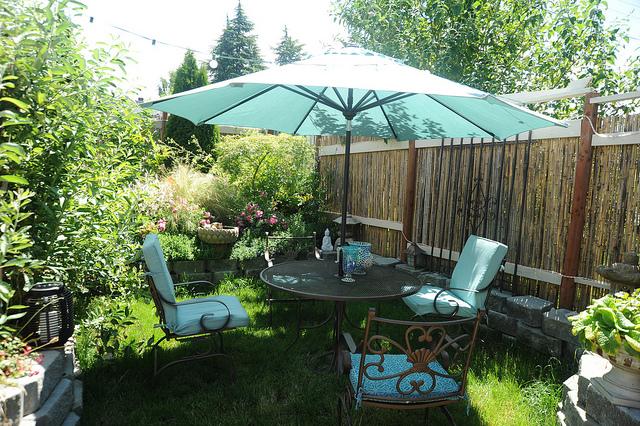Are all chairs alike?
Quick response, please. No. What kind of fence is that?
Be succinct. Wood. What kind of flowers are in this photo?
Keep it brief. Roses. 